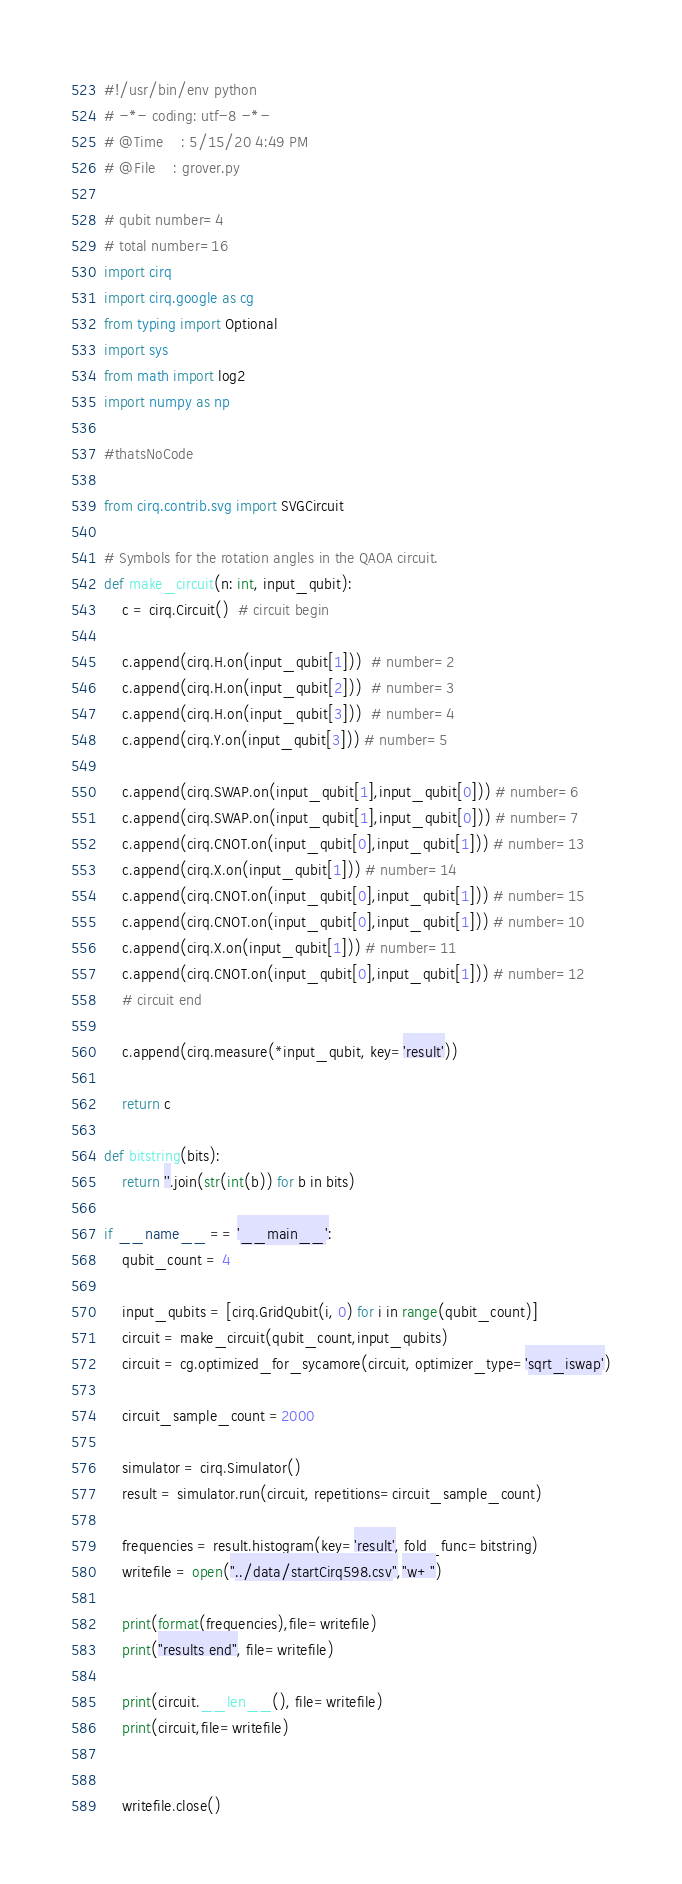<code> <loc_0><loc_0><loc_500><loc_500><_Python_>#!/usr/bin/env python
# -*- coding: utf-8 -*-
# @Time    : 5/15/20 4:49 PM
# @File    : grover.py

# qubit number=4
# total number=16
import cirq
import cirq.google as cg
from typing import Optional
import sys
from math import log2
import numpy as np

#thatsNoCode

from cirq.contrib.svg import SVGCircuit

# Symbols for the rotation angles in the QAOA circuit.
def make_circuit(n: int, input_qubit):
    c = cirq.Circuit()  # circuit begin

    c.append(cirq.H.on(input_qubit[1]))  # number=2
    c.append(cirq.H.on(input_qubit[2]))  # number=3
    c.append(cirq.H.on(input_qubit[3]))  # number=4
    c.append(cirq.Y.on(input_qubit[3])) # number=5

    c.append(cirq.SWAP.on(input_qubit[1],input_qubit[0])) # number=6
    c.append(cirq.SWAP.on(input_qubit[1],input_qubit[0])) # number=7
    c.append(cirq.CNOT.on(input_qubit[0],input_qubit[1])) # number=13
    c.append(cirq.X.on(input_qubit[1])) # number=14
    c.append(cirq.CNOT.on(input_qubit[0],input_qubit[1])) # number=15
    c.append(cirq.CNOT.on(input_qubit[0],input_qubit[1])) # number=10
    c.append(cirq.X.on(input_qubit[1])) # number=11
    c.append(cirq.CNOT.on(input_qubit[0],input_qubit[1])) # number=12
    # circuit end

    c.append(cirq.measure(*input_qubit, key='result'))

    return c

def bitstring(bits):
    return ''.join(str(int(b)) for b in bits)

if __name__ == '__main__':
    qubit_count = 4

    input_qubits = [cirq.GridQubit(i, 0) for i in range(qubit_count)]
    circuit = make_circuit(qubit_count,input_qubits)
    circuit = cg.optimized_for_sycamore(circuit, optimizer_type='sqrt_iswap')

    circuit_sample_count =2000

    simulator = cirq.Simulator()
    result = simulator.run(circuit, repetitions=circuit_sample_count)

    frequencies = result.histogram(key='result', fold_func=bitstring)
    writefile = open("../data/startCirq598.csv","w+")

    print(format(frequencies),file=writefile)
    print("results end", file=writefile)

    print(circuit.__len__(), file=writefile)
    print(circuit,file=writefile)


    writefile.close()</code> 